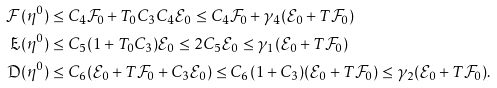Convert formula to latex. <formula><loc_0><loc_0><loc_500><loc_500>\mathcal { F } ( \eta ^ { 0 } ) & \leq C _ { 4 } \mathcal { F } _ { 0 } + T _ { 0 } C _ { 3 } C _ { 4 } \mathcal { E } _ { 0 } \leq C _ { 4 } \mathcal { F } _ { 0 } + \gamma _ { 4 } ( \mathcal { E } _ { 0 } + T \mathcal { F } _ { 0 } ) \\ \mathfrak { E } ( \eta ^ { 0 } ) & \leq C _ { 5 } ( 1 + T _ { 0 } C _ { 3 } ) \mathcal { E } _ { 0 } \leq 2 C _ { 5 } \mathcal { E } _ { 0 } \leq \gamma _ { 1 } ( \mathcal { E } _ { 0 } + T \mathcal { F } _ { 0 } ) \\ \mathfrak { D } ( \eta ^ { 0 } ) & \leq C _ { 6 } ( \mathcal { E } _ { 0 } + T \mathcal { F } _ { 0 } + C _ { 3 } \mathcal { E } _ { 0 } ) \leq C _ { 6 } ( 1 + C _ { 3 } ) ( \mathcal { E } _ { 0 } + T \mathcal { F } _ { 0 } ) \leq \gamma _ { 2 } ( \mathcal { E } _ { 0 } + T \mathcal { F } _ { 0 } ) .</formula> 